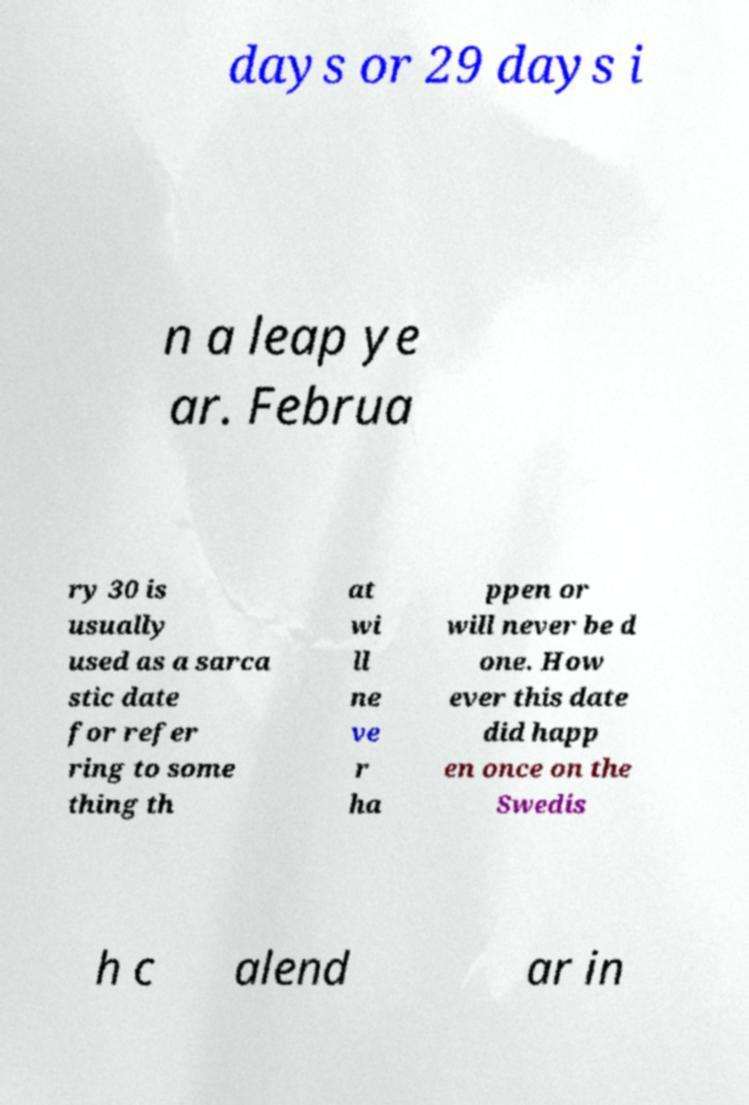Could you assist in decoding the text presented in this image and type it out clearly? days or 29 days i n a leap ye ar. Februa ry 30 is usually used as a sarca stic date for refer ring to some thing th at wi ll ne ve r ha ppen or will never be d one. How ever this date did happ en once on the Swedis h c alend ar in 